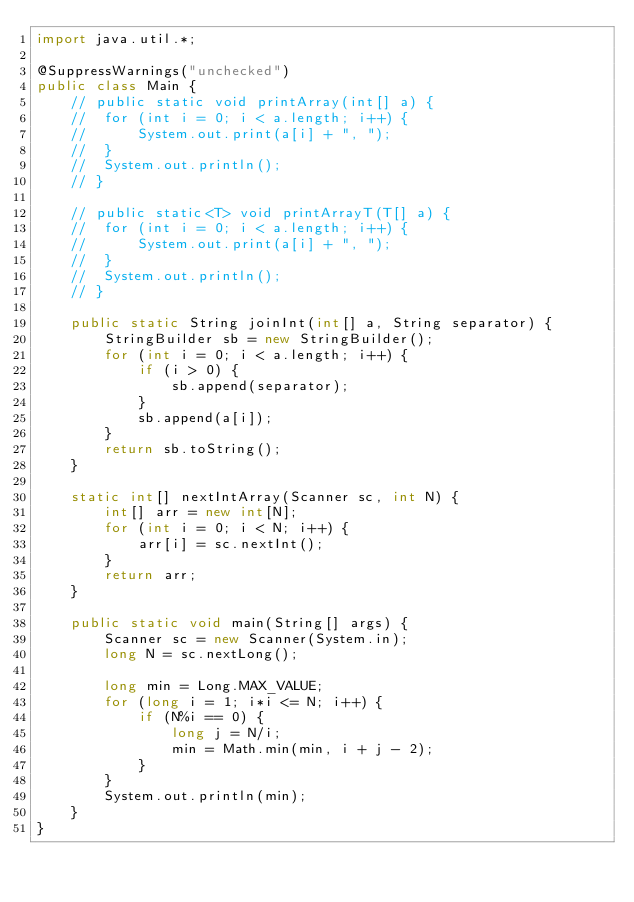<code> <loc_0><loc_0><loc_500><loc_500><_Java_>import java.util.*;

@SuppressWarnings("unchecked")
public class Main {
	// public static void printArray(int[] a) {
	// 	for (int i = 0; i < a.length; i++) {
	// 		System.out.print(a[i] + ", ");
	// 	}
	// 	System.out.println();
	// }

	// public static<T> void printArrayT(T[] a) {
	// 	for (int i = 0; i < a.length; i++) {
	// 		System.out.print(a[i] + ", ");
	// 	}
	// 	System.out.println();
	// }

	public static String joinInt(int[] a, String separator) {
		StringBuilder sb = new StringBuilder();
		for (int i = 0; i < a.length; i++) {
			if (i > 0) {
				sb.append(separator);
			}
			sb.append(a[i]);
		}
		return sb.toString();		
	}

	static int[] nextIntArray(Scanner sc, int N) {
		int[] arr = new int[N];
		for (int i = 0; i < N; i++) {
			arr[i] = sc.nextInt();
		}
		return arr;
	}

	public static void main(String[] args) {
		Scanner sc = new Scanner(System.in);
		long N = sc.nextLong();

		long min = Long.MAX_VALUE;
		for (long i = 1; i*i <= N; i++) {
			if (N%i == 0) {
				long j = N/i;
				min = Math.min(min, i + j - 2);
			}
		}
		System.out.println(min);
	}
}
</code> 